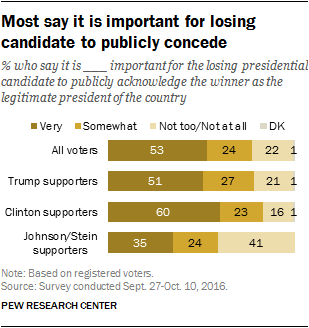Mention a couple of crucial points in this snapshot. According to the data, a significant percentage of all voters chose 'Don't Know' as their response. According to the data, Clinton supporters rate the importance of very and somewhat important issues as 2.515972222... 